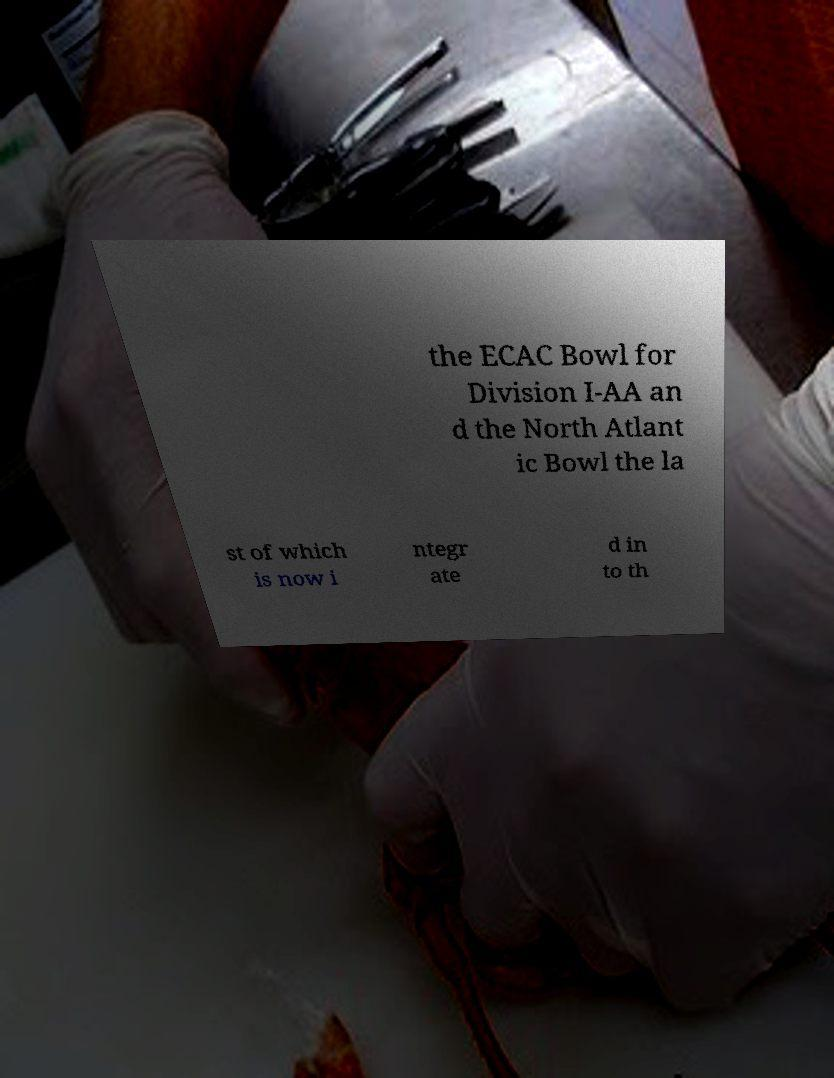Can you read and provide the text displayed in the image?This photo seems to have some interesting text. Can you extract and type it out for me? the ECAC Bowl for Division I-AA an d the North Atlant ic Bowl the la st of which is now i ntegr ate d in to th 